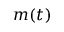<formula> <loc_0><loc_0><loc_500><loc_500>m ( t )</formula> 